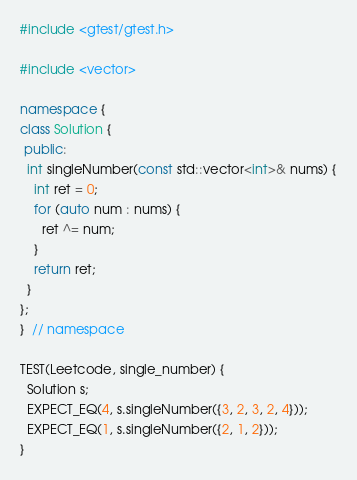<code> <loc_0><loc_0><loc_500><loc_500><_C++_>#include <gtest/gtest.h>

#include <vector>

namespace {
class Solution {
 public:
  int singleNumber(const std::vector<int>& nums) {
    int ret = 0;
    for (auto num : nums) {
      ret ^= num;
    }
    return ret;
  }
};
}  // namespace

TEST(Leetcode, single_number) {
  Solution s;
  EXPECT_EQ(4, s.singleNumber({3, 2, 3, 2, 4}));
  EXPECT_EQ(1, s.singleNumber({2, 1, 2}));
}
</code> 